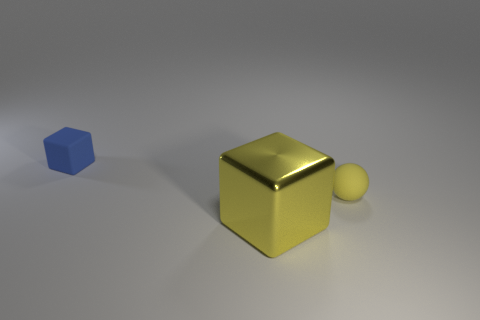Is there anything else that is the same material as the tiny yellow thing?
Your answer should be compact. Yes. Does the rubber object in front of the tiny blue matte thing have the same size as the cube that is in front of the matte cube?
Keep it short and to the point. No. What number of large objects are either gray shiny balls or matte things?
Offer a terse response. 0. What number of things are in front of the small blue rubber cube and left of the yellow matte ball?
Offer a terse response. 1. Do the small blue block and the yellow thing behind the large thing have the same material?
Your answer should be very brief. Yes. What number of yellow things are big things or small spheres?
Offer a very short reply. 2. Is there a yellow object of the same size as the matte cube?
Give a very brief answer. Yes. There is a block in front of the tiny rubber object that is right of the object behind the matte sphere; what is its material?
Give a very brief answer. Metal. Are there the same number of yellow spheres that are on the left side of the blue cube and large cyan balls?
Ensure brevity in your answer.  Yes. Does the block behind the big shiny cube have the same material as the cube in front of the yellow sphere?
Give a very brief answer. No. 